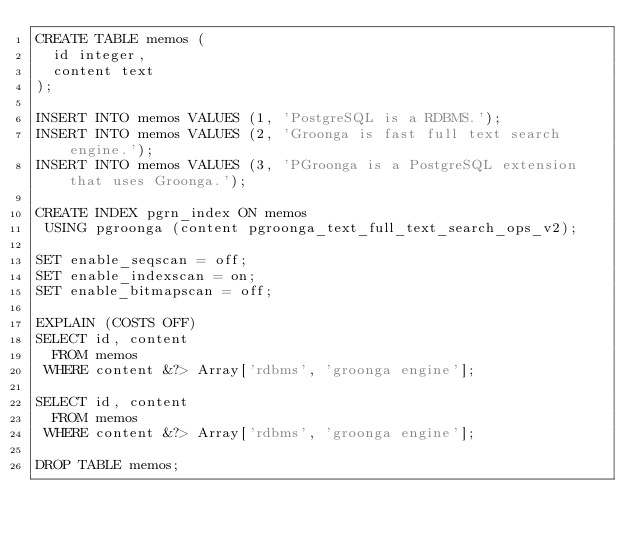<code> <loc_0><loc_0><loc_500><loc_500><_SQL_>CREATE TABLE memos (
  id integer,
  content text
);

INSERT INTO memos VALUES (1, 'PostgreSQL is a RDBMS.');
INSERT INTO memos VALUES (2, 'Groonga is fast full text search engine.');
INSERT INTO memos VALUES (3, 'PGroonga is a PostgreSQL extension that uses Groonga.');

CREATE INDEX pgrn_index ON memos
 USING pgroonga (content pgroonga_text_full_text_search_ops_v2);

SET enable_seqscan = off;
SET enable_indexscan = on;
SET enable_bitmapscan = off;

EXPLAIN (COSTS OFF)
SELECT id, content
  FROM memos
 WHERE content &?> Array['rdbms', 'groonga engine'];

SELECT id, content
  FROM memos
 WHERE content &?> Array['rdbms', 'groonga engine'];

DROP TABLE memos;
</code> 